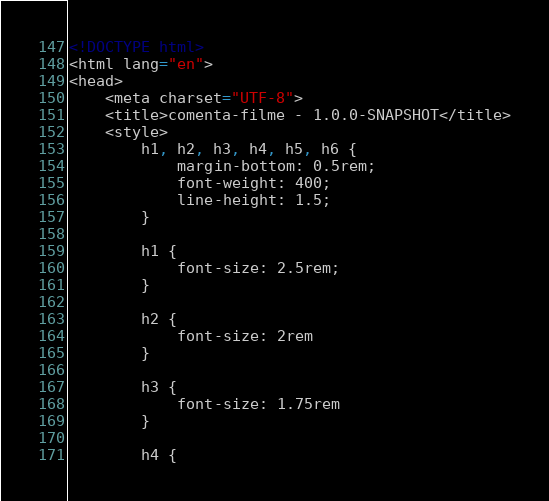Convert code to text. <code><loc_0><loc_0><loc_500><loc_500><_HTML_><!DOCTYPE html>
<html lang="en">
<head>
    <meta charset="UTF-8">
    <title>comenta-filme - 1.0.0-SNAPSHOT</title>
    <style>
        h1, h2, h3, h4, h5, h6 {
            margin-bottom: 0.5rem;
            font-weight: 400;
            line-height: 1.5;
        }

        h1 {
            font-size: 2.5rem;
        }

        h2 {
            font-size: 2rem
        }

        h3 {
            font-size: 1.75rem
        }

        h4 {</code> 